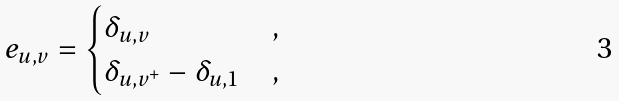<formula> <loc_0><loc_0><loc_500><loc_500>e _ { u , v } = \begin{cases} \delta _ { u , v } & , \\ \delta _ { u , v ^ { + } } - \delta _ { u , 1 } & , \end{cases}</formula> 